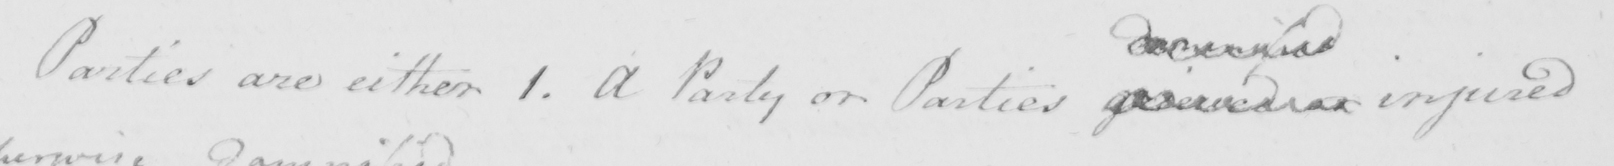What is written in this line of handwriting? Parties are either 1 . A Party or Parties grieved or injured 